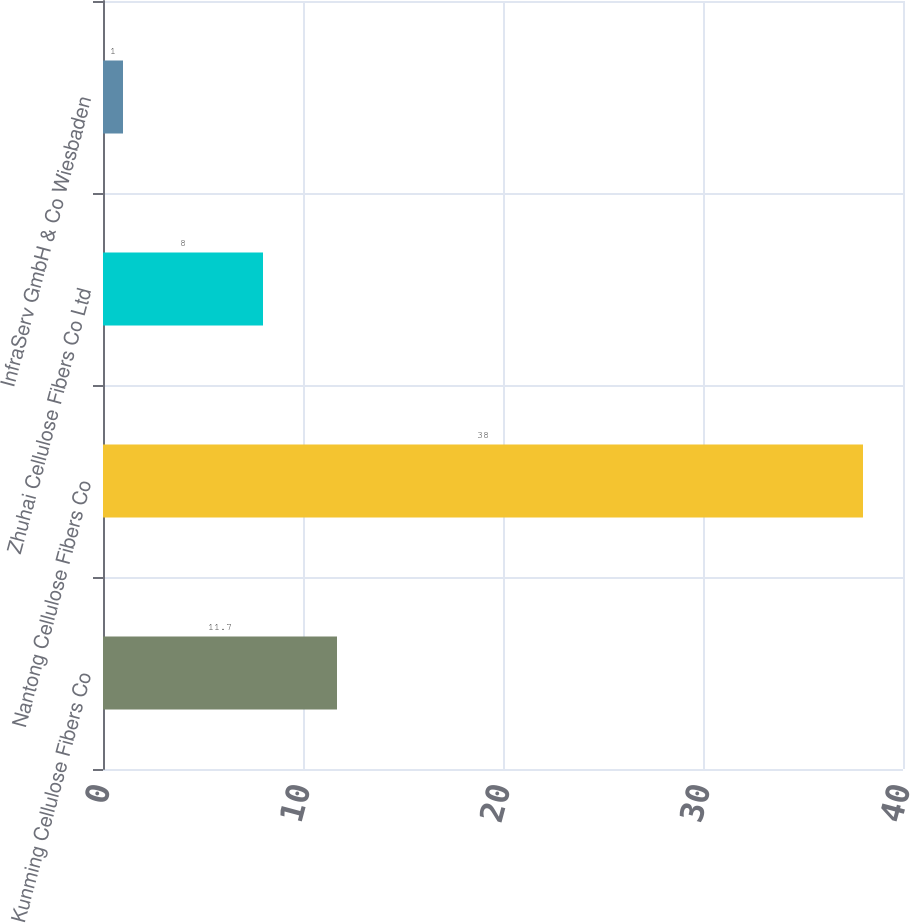Convert chart. <chart><loc_0><loc_0><loc_500><loc_500><bar_chart><fcel>Kunming Cellulose Fibers Co<fcel>Nantong Cellulose Fibers Co<fcel>Zhuhai Cellulose Fibers Co Ltd<fcel>InfraServ GmbH & Co Wiesbaden<nl><fcel>11.7<fcel>38<fcel>8<fcel>1<nl></chart> 